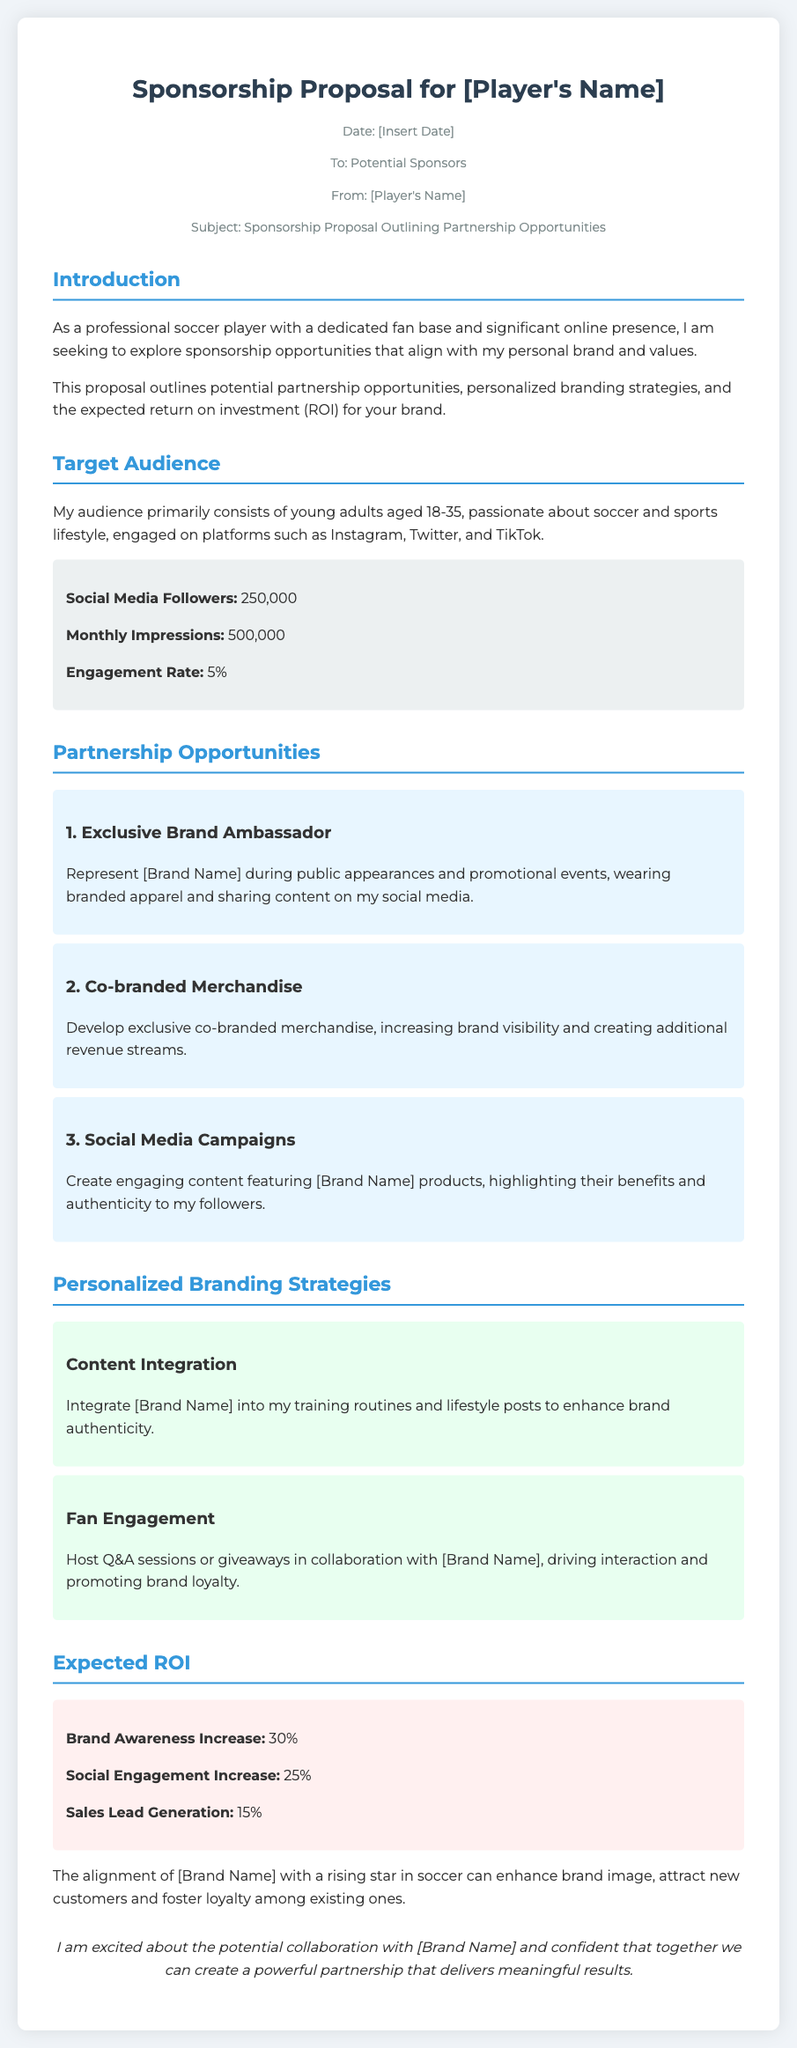what is the date of the memo? The date is indicated in the meta section of the document, but it is marked as [Insert Date] to be filled in later.
Answer: [Insert Date] who is the memo addressed to? The memo specifies in the meta section that it is addressed to Potential Sponsors.
Answer: Potential Sponsors what is the engagement rate mentioned? The engagement rate is provided in the statistics section as part of audience demographics.
Answer: 5% what is the brand awareness increase expected? The expected brand awareness increase is stated under the Expected ROI section of the document.
Answer: 30% what are the three partnership opportunities listed? The document includes three partnership opportunities that are titled: Exclusive Brand Ambassador, Co-branded Merchandise, and Social Media Campaigns.
Answer: Exclusive Brand Ambassador, Co-branded Merchandise, Social Media Campaigns which section discusses personalized branding strategies? The section that covers personalized branding strategies is titled "Personalized Branding Strategies."
Answer: Personalized Branding Strategies how many social media followers does the player have? The number of social media followers is listed in the target audience statistics.
Answer: 250,000 what is the expected social engagement increase? The expected increase in social engagement is mentioned in the Expected ROI section.
Answer: 25% 